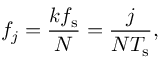<formula> <loc_0><loc_0><loc_500><loc_500>f _ { j } = \frac { k f _ { s } } { N } = \frac { j } { N T _ { s } } ,</formula> 